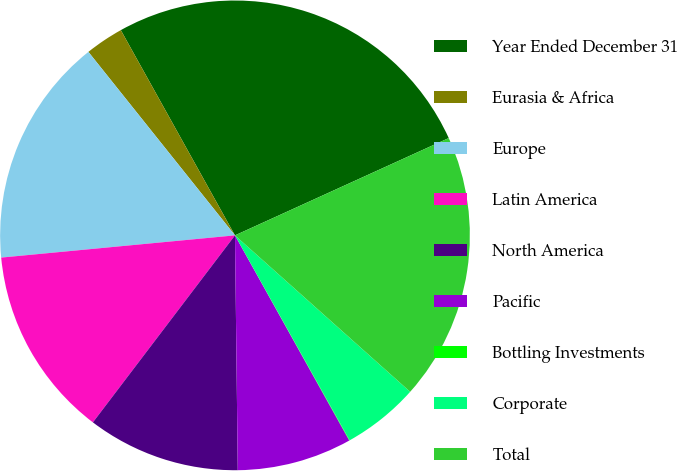Convert chart. <chart><loc_0><loc_0><loc_500><loc_500><pie_chart><fcel>Year Ended December 31<fcel>Eurasia & Africa<fcel>Europe<fcel>Latin America<fcel>North America<fcel>Pacific<fcel>Bottling Investments<fcel>Corporate<fcel>Total<nl><fcel>26.28%<fcel>2.65%<fcel>15.78%<fcel>13.15%<fcel>10.53%<fcel>7.9%<fcel>0.03%<fcel>5.28%<fcel>18.4%<nl></chart> 